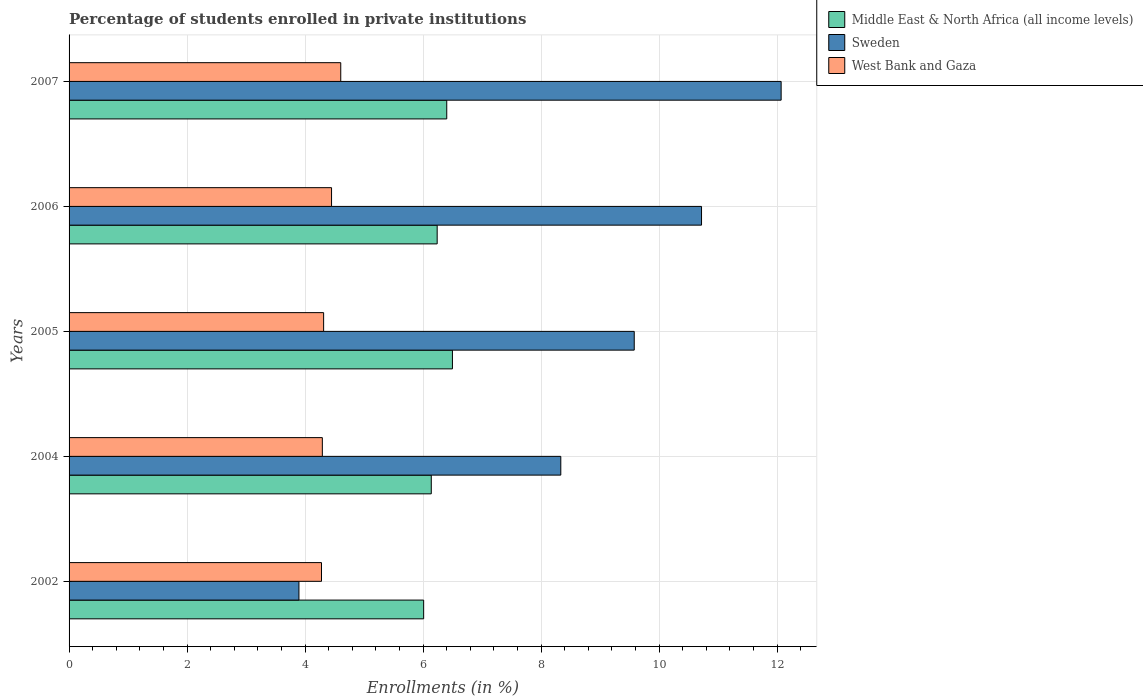Are the number of bars on each tick of the Y-axis equal?
Your answer should be very brief. Yes. In how many cases, is the number of bars for a given year not equal to the number of legend labels?
Keep it short and to the point. 0. What is the percentage of trained teachers in Middle East & North Africa (all income levels) in 2006?
Offer a terse response. 6.24. Across all years, what is the maximum percentage of trained teachers in West Bank and Gaza?
Your answer should be compact. 4.61. Across all years, what is the minimum percentage of trained teachers in Middle East & North Africa (all income levels)?
Keep it short and to the point. 6.01. In which year was the percentage of trained teachers in Sweden minimum?
Your answer should be very brief. 2002. What is the total percentage of trained teachers in Sweden in the graph?
Keep it short and to the point. 44.6. What is the difference between the percentage of trained teachers in West Bank and Gaza in 2005 and that in 2007?
Make the answer very short. -0.29. What is the difference between the percentage of trained teachers in Middle East & North Africa (all income levels) in 2007 and the percentage of trained teachers in West Bank and Gaza in 2002?
Offer a terse response. 2.12. What is the average percentage of trained teachers in West Bank and Gaza per year?
Offer a very short reply. 4.39. In the year 2007, what is the difference between the percentage of trained teachers in West Bank and Gaza and percentage of trained teachers in Middle East & North Africa (all income levels)?
Offer a very short reply. -1.8. What is the ratio of the percentage of trained teachers in West Bank and Gaza in 2002 to that in 2007?
Keep it short and to the point. 0.93. What is the difference between the highest and the second highest percentage of trained teachers in Sweden?
Provide a succinct answer. 1.35. What is the difference between the highest and the lowest percentage of trained teachers in West Bank and Gaza?
Your answer should be compact. 0.33. In how many years, is the percentage of trained teachers in Middle East & North Africa (all income levels) greater than the average percentage of trained teachers in Middle East & North Africa (all income levels) taken over all years?
Offer a terse response. 2. Is the sum of the percentage of trained teachers in West Bank and Gaza in 2002 and 2005 greater than the maximum percentage of trained teachers in Middle East & North Africa (all income levels) across all years?
Your response must be concise. Yes. What does the 1st bar from the bottom in 2002 represents?
Your answer should be compact. Middle East & North Africa (all income levels). How many bars are there?
Offer a very short reply. 15. How many years are there in the graph?
Your answer should be very brief. 5. What is the difference between two consecutive major ticks on the X-axis?
Your answer should be very brief. 2. Does the graph contain any zero values?
Make the answer very short. No. Does the graph contain grids?
Give a very brief answer. Yes. Where does the legend appear in the graph?
Give a very brief answer. Top right. How are the legend labels stacked?
Give a very brief answer. Vertical. What is the title of the graph?
Provide a succinct answer. Percentage of students enrolled in private institutions. Does "Puerto Rico" appear as one of the legend labels in the graph?
Your answer should be very brief. No. What is the label or title of the X-axis?
Your answer should be very brief. Enrollments (in %). What is the label or title of the Y-axis?
Your response must be concise. Years. What is the Enrollments (in %) of Middle East & North Africa (all income levels) in 2002?
Offer a terse response. 6.01. What is the Enrollments (in %) of Sweden in 2002?
Make the answer very short. 3.9. What is the Enrollments (in %) of West Bank and Gaza in 2002?
Offer a very short reply. 4.28. What is the Enrollments (in %) in Middle East & North Africa (all income levels) in 2004?
Offer a very short reply. 6.14. What is the Enrollments (in %) of Sweden in 2004?
Ensure brevity in your answer.  8.33. What is the Enrollments (in %) in West Bank and Gaza in 2004?
Your response must be concise. 4.29. What is the Enrollments (in %) of Middle East & North Africa (all income levels) in 2005?
Give a very brief answer. 6.5. What is the Enrollments (in %) in Sweden in 2005?
Offer a terse response. 9.58. What is the Enrollments (in %) of West Bank and Gaza in 2005?
Ensure brevity in your answer.  4.31. What is the Enrollments (in %) of Middle East & North Africa (all income levels) in 2006?
Keep it short and to the point. 6.24. What is the Enrollments (in %) in Sweden in 2006?
Give a very brief answer. 10.72. What is the Enrollments (in %) of West Bank and Gaza in 2006?
Your answer should be very brief. 4.45. What is the Enrollments (in %) of Middle East & North Africa (all income levels) in 2007?
Your answer should be compact. 6.4. What is the Enrollments (in %) of Sweden in 2007?
Make the answer very short. 12.07. What is the Enrollments (in %) in West Bank and Gaza in 2007?
Provide a short and direct response. 4.61. Across all years, what is the maximum Enrollments (in %) in Middle East & North Africa (all income levels)?
Your response must be concise. 6.5. Across all years, what is the maximum Enrollments (in %) in Sweden?
Offer a terse response. 12.07. Across all years, what is the maximum Enrollments (in %) in West Bank and Gaza?
Provide a short and direct response. 4.61. Across all years, what is the minimum Enrollments (in %) in Middle East & North Africa (all income levels)?
Your answer should be very brief. 6.01. Across all years, what is the minimum Enrollments (in %) in Sweden?
Your response must be concise. 3.9. Across all years, what is the minimum Enrollments (in %) in West Bank and Gaza?
Ensure brevity in your answer.  4.28. What is the total Enrollments (in %) in Middle East & North Africa (all income levels) in the graph?
Your answer should be compact. 31.29. What is the total Enrollments (in %) in Sweden in the graph?
Give a very brief answer. 44.6. What is the total Enrollments (in %) in West Bank and Gaza in the graph?
Provide a succinct answer. 21.94. What is the difference between the Enrollments (in %) in Middle East & North Africa (all income levels) in 2002 and that in 2004?
Ensure brevity in your answer.  -0.13. What is the difference between the Enrollments (in %) in Sweden in 2002 and that in 2004?
Your answer should be very brief. -4.44. What is the difference between the Enrollments (in %) of West Bank and Gaza in 2002 and that in 2004?
Your answer should be very brief. -0.01. What is the difference between the Enrollments (in %) of Middle East & North Africa (all income levels) in 2002 and that in 2005?
Provide a succinct answer. -0.49. What is the difference between the Enrollments (in %) of Sweden in 2002 and that in 2005?
Ensure brevity in your answer.  -5.68. What is the difference between the Enrollments (in %) of West Bank and Gaza in 2002 and that in 2005?
Give a very brief answer. -0.04. What is the difference between the Enrollments (in %) of Middle East & North Africa (all income levels) in 2002 and that in 2006?
Offer a terse response. -0.23. What is the difference between the Enrollments (in %) in Sweden in 2002 and that in 2006?
Keep it short and to the point. -6.82. What is the difference between the Enrollments (in %) in West Bank and Gaza in 2002 and that in 2006?
Provide a short and direct response. -0.17. What is the difference between the Enrollments (in %) of Middle East & North Africa (all income levels) in 2002 and that in 2007?
Make the answer very short. -0.39. What is the difference between the Enrollments (in %) in Sweden in 2002 and that in 2007?
Ensure brevity in your answer.  -8.17. What is the difference between the Enrollments (in %) of West Bank and Gaza in 2002 and that in 2007?
Offer a very short reply. -0.33. What is the difference between the Enrollments (in %) in Middle East & North Africa (all income levels) in 2004 and that in 2005?
Your answer should be compact. -0.36. What is the difference between the Enrollments (in %) in Sweden in 2004 and that in 2005?
Your answer should be very brief. -1.24. What is the difference between the Enrollments (in %) of West Bank and Gaza in 2004 and that in 2005?
Make the answer very short. -0.02. What is the difference between the Enrollments (in %) in Middle East & North Africa (all income levels) in 2004 and that in 2006?
Keep it short and to the point. -0.1. What is the difference between the Enrollments (in %) of Sweden in 2004 and that in 2006?
Give a very brief answer. -2.39. What is the difference between the Enrollments (in %) of West Bank and Gaza in 2004 and that in 2006?
Give a very brief answer. -0.16. What is the difference between the Enrollments (in %) of Middle East & North Africa (all income levels) in 2004 and that in 2007?
Your answer should be very brief. -0.26. What is the difference between the Enrollments (in %) of Sweden in 2004 and that in 2007?
Your answer should be compact. -3.73. What is the difference between the Enrollments (in %) in West Bank and Gaza in 2004 and that in 2007?
Provide a short and direct response. -0.31. What is the difference between the Enrollments (in %) of Middle East & North Africa (all income levels) in 2005 and that in 2006?
Offer a terse response. 0.26. What is the difference between the Enrollments (in %) in Sweden in 2005 and that in 2006?
Provide a succinct answer. -1.14. What is the difference between the Enrollments (in %) of West Bank and Gaza in 2005 and that in 2006?
Provide a short and direct response. -0.13. What is the difference between the Enrollments (in %) in Middle East & North Africa (all income levels) in 2005 and that in 2007?
Provide a succinct answer. 0.1. What is the difference between the Enrollments (in %) in Sweden in 2005 and that in 2007?
Your answer should be very brief. -2.49. What is the difference between the Enrollments (in %) in West Bank and Gaza in 2005 and that in 2007?
Your answer should be very brief. -0.29. What is the difference between the Enrollments (in %) of Middle East & North Africa (all income levels) in 2006 and that in 2007?
Keep it short and to the point. -0.16. What is the difference between the Enrollments (in %) of Sweden in 2006 and that in 2007?
Provide a succinct answer. -1.35. What is the difference between the Enrollments (in %) in West Bank and Gaza in 2006 and that in 2007?
Provide a succinct answer. -0.16. What is the difference between the Enrollments (in %) in Middle East & North Africa (all income levels) in 2002 and the Enrollments (in %) in Sweden in 2004?
Ensure brevity in your answer.  -2.32. What is the difference between the Enrollments (in %) of Middle East & North Africa (all income levels) in 2002 and the Enrollments (in %) of West Bank and Gaza in 2004?
Your response must be concise. 1.72. What is the difference between the Enrollments (in %) in Sweden in 2002 and the Enrollments (in %) in West Bank and Gaza in 2004?
Keep it short and to the point. -0.4. What is the difference between the Enrollments (in %) in Middle East & North Africa (all income levels) in 2002 and the Enrollments (in %) in Sweden in 2005?
Make the answer very short. -3.57. What is the difference between the Enrollments (in %) in Middle East & North Africa (all income levels) in 2002 and the Enrollments (in %) in West Bank and Gaza in 2005?
Your response must be concise. 1.7. What is the difference between the Enrollments (in %) in Sweden in 2002 and the Enrollments (in %) in West Bank and Gaza in 2005?
Your answer should be compact. -0.42. What is the difference between the Enrollments (in %) in Middle East & North Africa (all income levels) in 2002 and the Enrollments (in %) in Sweden in 2006?
Keep it short and to the point. -4.71. What is the difference between the Enrollments (in %) of Middle East & North Africa (all income levels) in 2002 and the Enrollments (in %) of West Bank and Gaza in 2006?
Give a very brief answer. 1.56. What is the difference between the Enrollments (in %) of Sweden in 2002 and the Enrollments (in %) of West Bank and Gaza in 2006?
Provide a succinct answer. -0.55. What is the difference between the Enrollments (in %) in Middle East & North Africa (all income levels) in 2002 and the Enrollments (in %) in Sweden in 2007?
Provide a succinct answer. -6.06. What is the difference between the Enrollments (in %) in Middle East & North Africa (all income levels) in 2002 and the Enrollments (in %) in West Bank and Gaza in 2007?
Make the answer very short. 1.41. What is the difference between the Enrollments (in %) of Sweden in 2002 and the Enrollments (in %) of West Bank and Gaza in 2007?
Provide a short and direct response. -0.71. What is the difference between the Enrollments (in %) in Middle East & North Africa (all income levels) in 2004 and the Enrollments (in %) in Sweden in 2005?
Keep it short and to the point. -3.44. What is the difference between the Enrollments (in %) in Middle East & North Africa (all income levels) in 2004 and the Enrollments (in %) in West Bank and Gaza in 2005?
Offer a very short reply. 1.82. What is the difference between the Enrollments (in %) of Sweden in 2004 and the Enrollments (in %) of West Bank and Gaza in 2005?
Provide a short and direct response. 4.02. What is the difference between the Enrollments (in %) of Middle East & North Africa (all income levels) in 2004 and the Enrollments (in %) of Sweden in 2006?
Your answer should be compact. -4.58. What is the difference between the Enrollments (in %) in Middle East & North Africa (all income levels) in 2004 and the Enrollments (in %) in West Bank and Gaza in 2006?
Make the answer very short. 1.69. What is the difference between the Enrollments (in %) of Sweden in 2004 and the Enrollments (in %) of West Bank and Gaza in 2006?
Offer a very short reply. 3.89. What is the difference between the Enrollments (in %) in Middle East & North Africa (all income levels) in 2004 and the Enrollments (in %) in Sweden in 2007?
Your answer should be compact. -5.93. What is the difference between the Enrollments (in %) of Middle East & North Africa (all income levels) in 2004 and the Enrollments (in %) of West Bank and Gaza in 2007?
Offer a terse response. 1.53. What is the difference between the Enrollments (in %) of Sweden in 2004 and the Enrollments (in %) of West Bank and Gaza in 2007?
Your answer should be very brief. 3.73. What is the difference between the Enrollments (in %) of Middle East & North Africa (all income levels) in 2005 and the Enrollments (in %) of Sweden in 2006?
Your response must be concise. -4.22. What is the difference between the Enrollments (in %) of Middle East & North Africa (all income levels) in 2005 and the Enrollments (in %) of West Bank and Gaza in 2006?
Provide a succinct answer. 2.05. What is the difference between the Enrollments (in %) in Sweden in 2005 and the Enrollments (in %) in West Bank and Gaza in 2006?
Provide a short and direct response. 5.13. What is the difference between the Enrollments (in %) of Middle East & North Africa (all income levels) in 2005 and the Enrollments (in %) of Sweden in 2007?
Give a very brief answer. -5.57. What is the difference between the Enrollments (in %) of Middle East & North Africa (all income levels) in 2005 and the Enrollments (in %) of West Bank and Gaza in 2007?
Ensure brevity in your answer.  1.89. What is the difference between the Enrollments (in %) in Sweden in 2005 and the Enrollments (in %) in West Bank and Gaza in 2007?
Ensure brevity in your answer.  4.97. What is the difference between the Enrollments (in %) of Middle East & North Africa (all income levels) in 2006 and the Enrollments (in %) of Sweden in 2007?
Ensure brevity in your answer.  -5.83. What is the difference between the Enrollments (in %) of Middle East & North Africa (all income levels) in 2006 and the Enrollments (in %) of West Bank and Gaza in 2007?
Make the answer very short. 1.63. What is the difference between the Enrollments (in %) in Sweden in 2006 and the Enrollments (in %) in West Bank and Gaza in 2007?
Keep it short and to the point. 6.12. What is the average Enrollments (in %) in Middle East & North Africa (all income levels) per year?
Offer a very short reply. 6.26. What is the average Enrollments (in %) of Sweden per year?
Your answer should be very brief. 8.92. What is the average Enrollments (in %) in West Bank and Gaza per year?
Your answer should be very brief. 4.39. In the year 2002, what is the difference between the Enrollments (in %) of Middle East & North Africa (all income levels) and Enrollments (in %) of Sweden?
Keep it short and to the point. 2.11. In the year 2002, what is the difference between the Enrollments (in %) of Middle East & North Africa (all income levels) and Enrollments (in %) of West Bank and Gaza?
Keep it short and to the point. 1.73. In the year 2002, what is the difference between the Enrollments (in %) of Sweden and Enrollments (in %) of West Bank and Gaza?
Offer a very short reply. -0.38. In the year 2004, what is the difference between the Enrollments (in %) in Middle East & North Africa (all income levels) and Enrollments (in %) in Sweden?
Ensure brevity in your answer.  -2.2. In the year 2004, what is the difference between the Enrollments (in %) in Middle East & North Africa (all income levels) and Enrollments (in %) in West Bank and Gaza?
Keep it short and to the point. 1.85. In the year 2004, what is the difference between the Enrollments (in %) in Sweden and Enrollments (in %) in West Bank and Gaza?
Your answer should be very brief. 4.04. In the year 2005, what is the difference between the Enrollments (in %) in Middle East & North Africa (all income levels) and Enrollments (in %) in Sweden?
Ensure brevity in your answer.  -3.08. In the year 2005, what is the difference between the Enrollments (in %) in Middle East & North Africa (all income levels) and Enrollments (in %) in West Bank and Gaza?
Offer a terse response. 2.18. In the year 2005, what is the difference between the Enrollments (in %) of Sweden and Enrollments (in %) of West Bank and Gaza?
Ensure brevity in your answer.  5.27. In the year 2006, what is the difference between the Enrollments (in %) of Middle East & North Africa (all income levels) and Enrollments (in %) of Sweden?
Offer a very short reply. -4.48. In the year 2006, what is the difference between the Enrollments (in %) in Middle East & North Africa (all income levels) and Enrollments (in %) in West Bank and Gaza?
Provide a short and direct response. 1.79. In the year 2006, what is the difference between the Enrollments (in %) in Sweden and Enrollments (in %) in West Bank and Gaza?
Keep it short and to the point. 6.27. In the year 2007, what is the difference between the Enrollments (in %) in Middle East & North Africa (all income levels) and Enrollments (in %) in Sweden?
Keep it short and to the point. -5.67. In the year 2007, what is the difference between the Enrollments (in %) of Middle East & North Africa (all income levels) and Enrollments (in %) of West Bank and Gaza?
Keep it short and to the point. 1.8. In the year 2007, what is the difference between the Enrollments (in %) in Sweden and Enrollments (in %) in West Bank and Gaza?
Provide a succinct answer. 7.46. What is the ratio of the Enrollments (in %) of Middle East & North Africa (all income levels) in 2002 to that in 2004?
Offer a very short reply. 0.98. What is the ratio of the Enrollments (in %) in Sweden in 2002 to that in 2004?
Your answer should be compact. 0.47. What is the ratio of the Enrollments (in %) in West Bank and Gaza in 2002 to that in 2004?
Offer a very short reply. 1. What is the ratio of the Enrollments (in %) in Middle East & North Africa (all income levels) in 2002 to that in 2005?
Offer a terse response. 0.92. What is the ratio of the Enrollments (in %) of Sweden in 2002 to that in 2005?
Provide a succinct answer. 0.41. What is the ratio of the Enrollments (in %) of West Bank and Gaza in 2002 to that in 2005?
Give a very brief answer. 0.99. What is the ratio of the Enrollments (in %) of Middle East & North Africa (all income levels) in 2002 to that in 2006?
Your answer should be compact. 0.96. What is the ratio of the Enrollments (in %) in Sweden in 2002 to that in 2006?
Give a very brief answer. 0.36. What is the ratio of the Enrollments (in %) in West Bank and Gaza in 2002 to that in 2006?
Offer a terse response. 0.96. What is the ratio of the Enrollments (in %) of Middle East & North Africa (all income levels) in 2002 to that in 2007?
Keep it short and to the point. 0.94. What is the ratio of the Enrollments (in %) of Sweden in 2002 to that in 2007?
Your answer should be very brief. 0.32. What is the ratio of the Enrollments (in %) in West Bank and Gaza in 2002 to that in 2007?
Offer a very short reply. 0.93. What is the ratio of the Enrollments (in %) in Middle East & North Africa (all income levels) in 2004 to that in 2005?
Provide a succinct answer. 0.94. What is the ratio of the Enrollments (in %) in Sweden in 2004 to that in 2005?
Provide a short and direct response. 0.87. What is the ratio of the Enrollments (in %) in Sweden in 2004 to that in 2006?
Make the answer very short. 0.78. What is the ratio of the Enrollments (in %) of West Bank and Gaza in 2004 to that in 2006?
Provide a short and direct response. 0.96. What is the ratio of the Enrollments (in %) of Middle East & North Africa (all income levels) in 2004 to that in 2007?
Your response must be concise. 0.96. What is the ratio of the Enrollments (in %) of Sweden in 2004 to that in 2007?
Your answer should be very brief. 0.69. What is the ratio of the Enrollments (in %) of West Bank and Gaza in 2004 to that in 2007?
Make the answer very short. 0.93. What is the ratio of the Enrollments (in %) in Middle East & North Africa (all income levels) in 2005 to that in 2006?
Your answer should be very brief. 1.04. What is the ratio of the Enrollments (in %) of Sweden in 2005 to that in 2006?
Offer a very short reply. 0.89. What is the ratio of the Enrollments (in %) in West Bank and Gaza in 2005 to that in 2006?
Keep it short and to the point. 0.97. What is the ratio of the Enrollments (in %) in Middle East & North Africa (all income levels) in 2005 to that in 2007?
Ensure brevity in your answer.  1.02. What is the ratio of the Enrollments (in %) in Sweden in 2005 to that in 2007?
Make the answer very short. 0.79. What is the ratio of the Enrollments (in %) in West Bank and Gaza in 2005 to that in 2007?
Your response must be concise. 0.94. What is the ratio of the Enrollments (in %) of Middle East & North Africa (all income levels) in 2006 to that in 2007?
Give a very brief answer. 0.97. What is the ratio of the Enrollments (in %) of Sweden in 2006 to that in 2007?
Provide a succinct answer. 0.89. What is the ratio of the Enrollments (in %) in West Bank and Gaza in 2006 to that in 2007?
Provide a short and direct response. 0.97. What is the difference between the highest and the second highest Enrollments (in %) of Middle East & North Africa (all income levels)?
Your response must be concise. 0.1. What is the difference between the highest and the second highest Enrollments (in %) in Sweden?
Offer a very short reply. 1.35. What is the difference between the highest and the second highest Enrollments (in %) in West Bank and Gaza?
Offer a very short reply. 0.16. What is the difference between the highest and the lowest Enrollments (in %) in Middle East & North Africa (all income levels)?
Offer a terse response. 0.49. What is the difference between the highest and the lowest Enrollments (in %) of Sweden?
Ensure brevity in your answer.  8.17. What is the difference between the highest and the lowest Enrollments (in %) of West Bank and Gaza?
Provide a short and direct response. 0.33. 